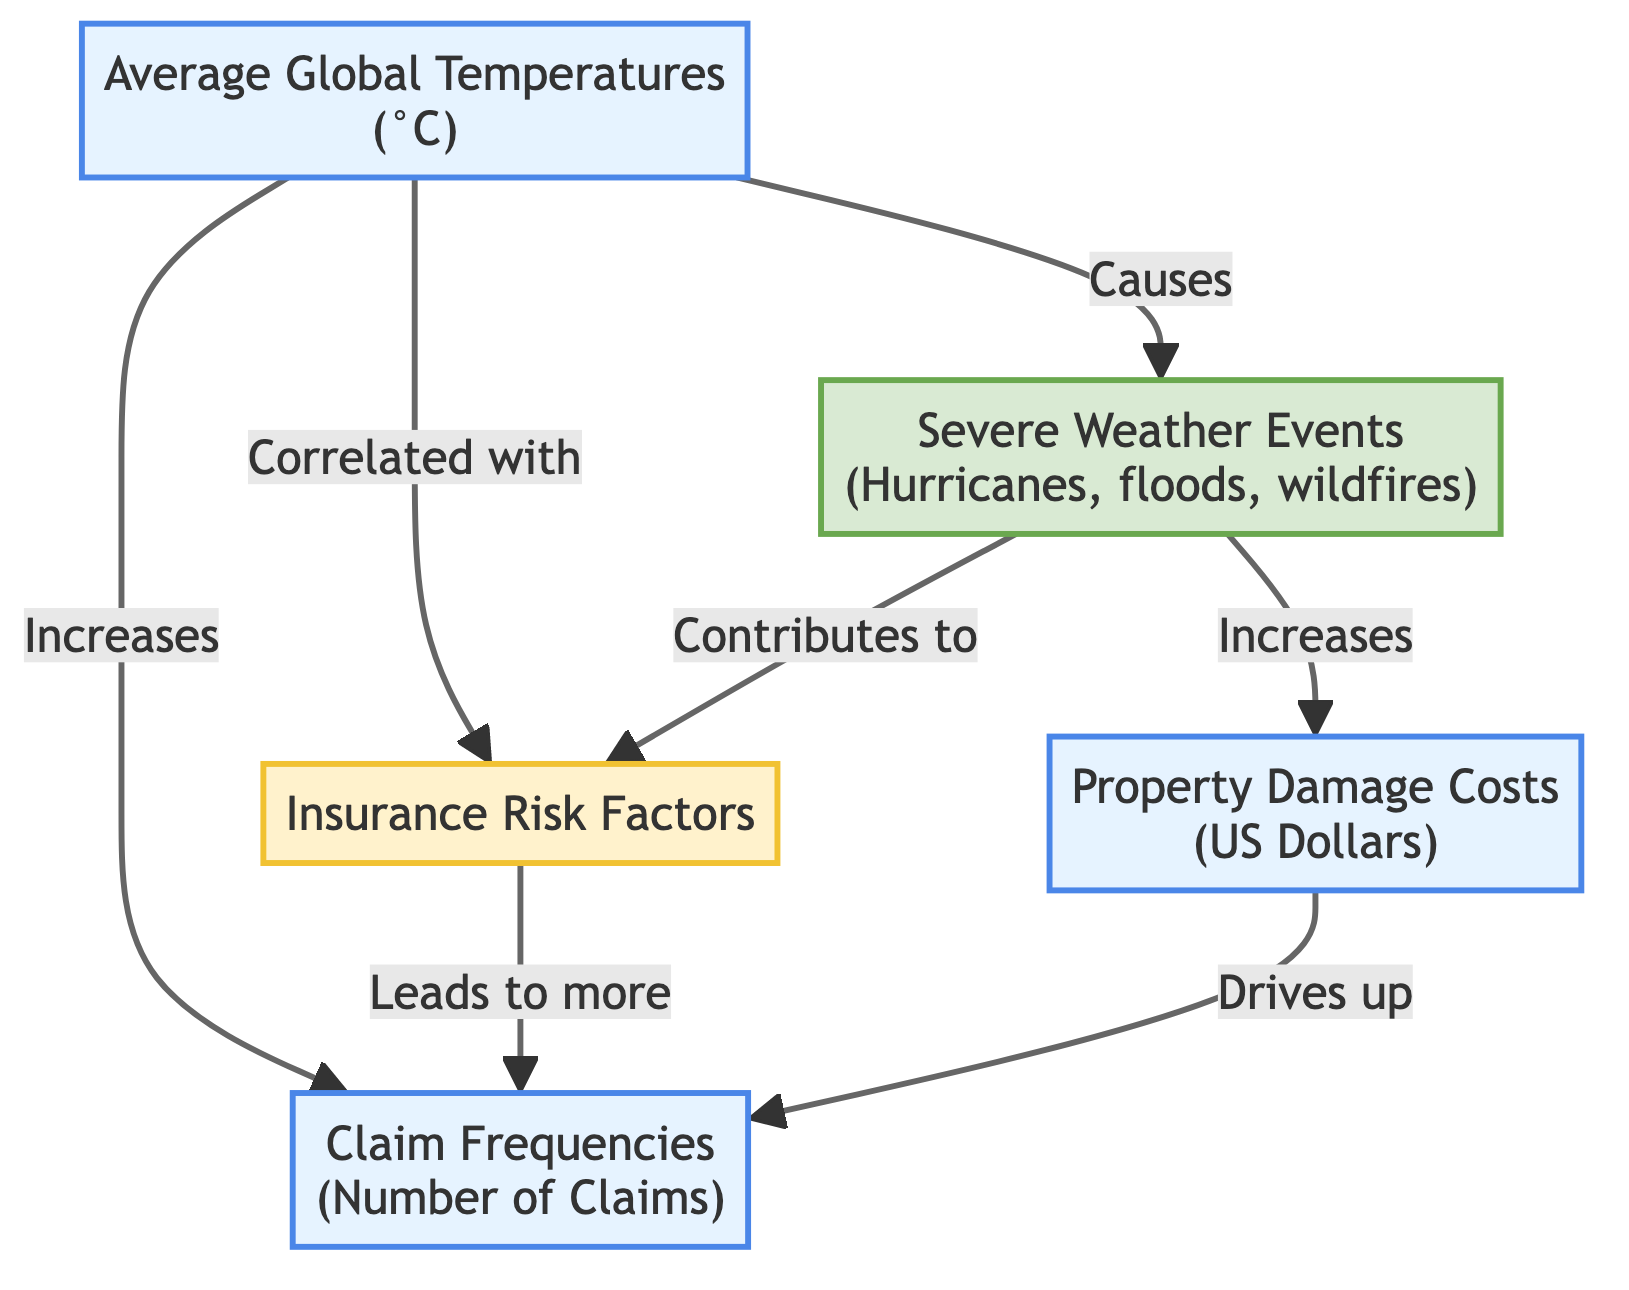What is the relationship between average global temperatures and insurance risk factors? The diagram indicates a direct correlation where an increase in average global temperatures is associated with increasing insurance risk factors. This is explicitly shown by the arrow labeled "Correlated with" between these two nodes.
Answer: Correlated with How many nodes are depicted in the diagram? To determine the number of nodes, count each distinct item in the diagram. The nodes are: Average Global Temperatures, Insurance Risk Factors, Claim Frequencies, Severe Weather Events, and Property Damage Costs. This results in a total of five nodes.
Answer: 5 What does the increase in average global temperatures lead to? The diagram shows that an increase in average global temperatures "Causes" severe weather events. This is shown by the directional arrow leading from the "Average Global Temperatures" node to the "Severe Weather Events" node.
Answer: Severe Weather Events Which factor directly drives up claim frequencies? The diagram illustrates that "Property Damage Costs" directly drive up claim frequencies. This is indicated by the arrow going from "Property Damage Costs" to "Claim Frequencies" labeled "Drives up."
Answer: Property Damage Costs What is one of the consequences of severe weather events? According to the diagram, one of the consequences of severe weather events is that they "Contribute to" increasing insurance risk factors. This is shown by the directional arrow connecting "Severe Weather Events" to "Insurance Risk Factors."
Answer: Contributes to How does property damage costs affect claim frequencies? The diagram indicates that property damage costs "Drives up" claim frequencies. This shows a direct relationship where increases in property damage costs lead to more claims being filed.
Answer: Drives up What type of events are correlated with the rise in insurance risk factors? The diagram specifies that severe weather events, including hurricanes, floods, and wildfires, are correlated with an increase in insurance risk factors. This is detailed under the "Severe Weather Events" node's connection to "Insurance Risk Factors."
Answer: Severe Weather Events What is the implication of increasing average global temperatures on property damage costs? The diagram states that increasing average global temperatures "Increases" property damage costs by leading to more severe weather events that cause damage. This relationship is shown with arrows indicating the direct connection.
Answer: Increases 